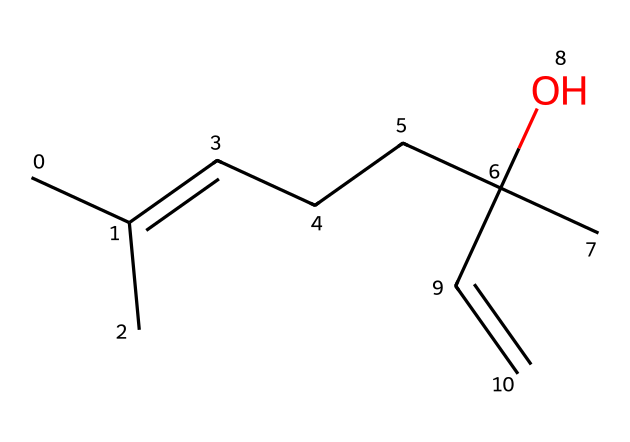What is the total number of carbon atoms in this molecule? By examining the SMILES representation, we identify each carbon (C) in the structure. Counting the 'C' characters in the SMILES, we find eight carbon atoms in total.
Answer: eight How many double bonds are present in this chemical? Analyzing the SMILES structure, we see the 'C=C' segment, indicating a double bond. There is only one such segment in the representation, indicating a single double bond.
Answer: one What is the functional group present in this molecule? The 'C(C)(O)' portion shows that there is a hydroxyl group (-OH) attached to a carbon, identifying it as an alcohol functional group in the molecule.
Answer: alcohol What type of scent is associated with this molecule? Linalool is widely recognized for its floral and pleasant aroma, often described as lavender-scented, which is characteristic of its chemical profile.
Answer: lavender Is this molecule considered a terpene? Linalool fits the definition of terpenes, being composed entirely of carbon and hydrogen and derived from plants, thus categorizing it as a terpene.
Answer: yes What is the molecular formula derived from the chemical structure? By analyzing the carbon (C), hydrogen (H), and oxygen (O) count represented, we deduce the molecular formula to be C10H18O, representing the components in their simplest form.
Answer: C10H18O How does this molecule contribute to the fragrance of lavender? The unique structure and presence of specific functional groups in linalool, such as the hydroxyl group, enhance its fragrance profile, making it an essential component in lavender-scented products.
Answer: fragrance profile 